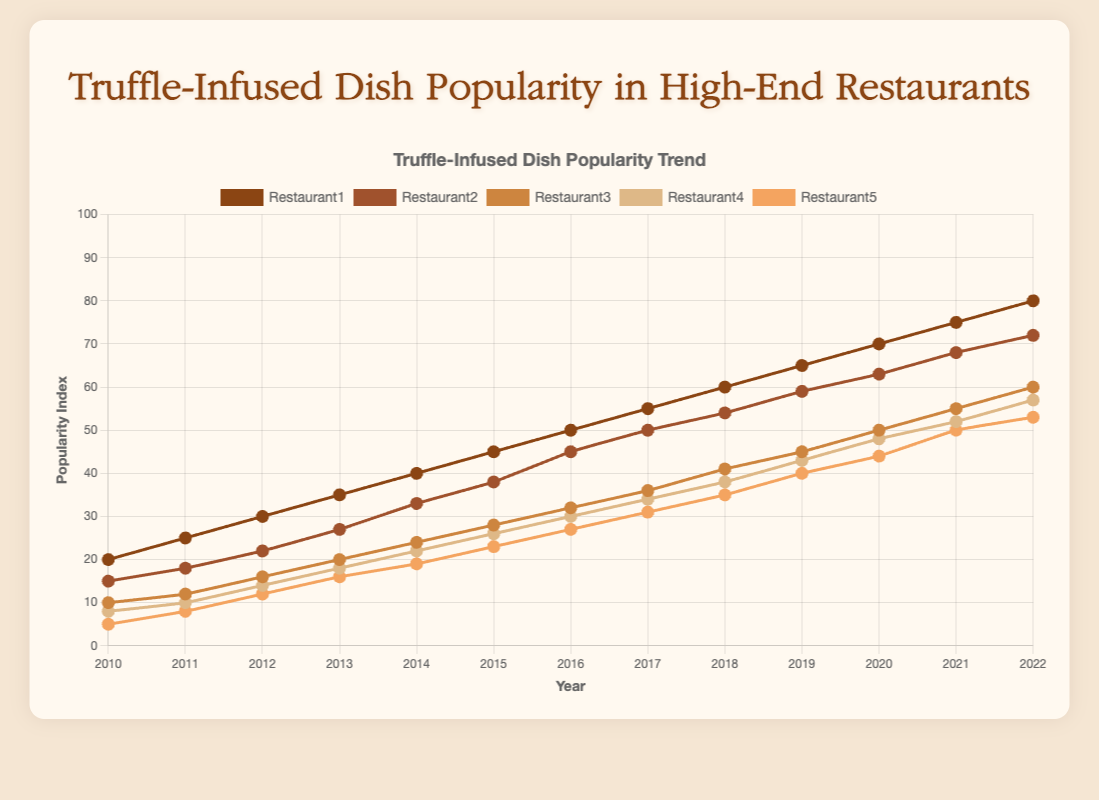What is the year when Restaurant1's popularity index first reached 45? We need to look at the line representing Restaurant1 and check when its value reached 45. From the data, it is in 2015.
Answer: 2015 Which restaurant had the lowest popularity index in 2012? We compare the popularity indexes of all restaurants in 2012. Restaurant5 had the lowest value of 12.
Answer: Restaurant5 Was the popularity index of Restaurant3 in 2021 higher than that of Restaurant4 in 2022? We compare the popularity indexes: Restaurant3 in 2021 had 55 while Restaurant4 in 2022 had 57.
Answer: No What is the average popularity index of Restaurant2 over the years 2010 and 2020? Sum the values of Restaurant2 for 2010 and 2020, then divide by 2. The values are 15 and 63 respectively. (15 + 63) / 2 = 39
Answer: 39 Between which two consecutive years did Restaurant5 see the biggest increase in popularity? Calculate the yearly differences for Restaurant5 and identify the maximum. The biggest increase was between 2011 (8) and 2012 (12), with an increase of 4.
Answer: 2011-2012 In what year did all five restaurants cumulatively reach a total popularity index of 150? Add up all popularity indexes for each year until the sum is 150. The sum reaches 150 in 2013: 35 (R1) + 27 (R2) + 20 (R3) + 18 (R4) + 16 (R5) = 116 for 2013. The total doesn't reach 150 in any specific year shown.
Answer: Not reached By visually inspecting the trends, which restaurant had the most consistent linear increase in popularity index from 2010 to 2022? All restaurants show increases, but Restaurant1 shows the most consistently linear growth.
Answer: Restaurant1 In how many years did Restaurant4 experience an increase in its popularity index from the previous year? Count the years where the popularity index for Restaurant4 increased compared to the previous year. This happened every year: 12 times.
Answer: 12 What is the range of the popularity index for Restaurant3 over the given period? The highest value for Restaurant3 is 60 in 2022, and the lowest is 10 in 2010. The range is 60 - 10 = 50.
Answer: 50 